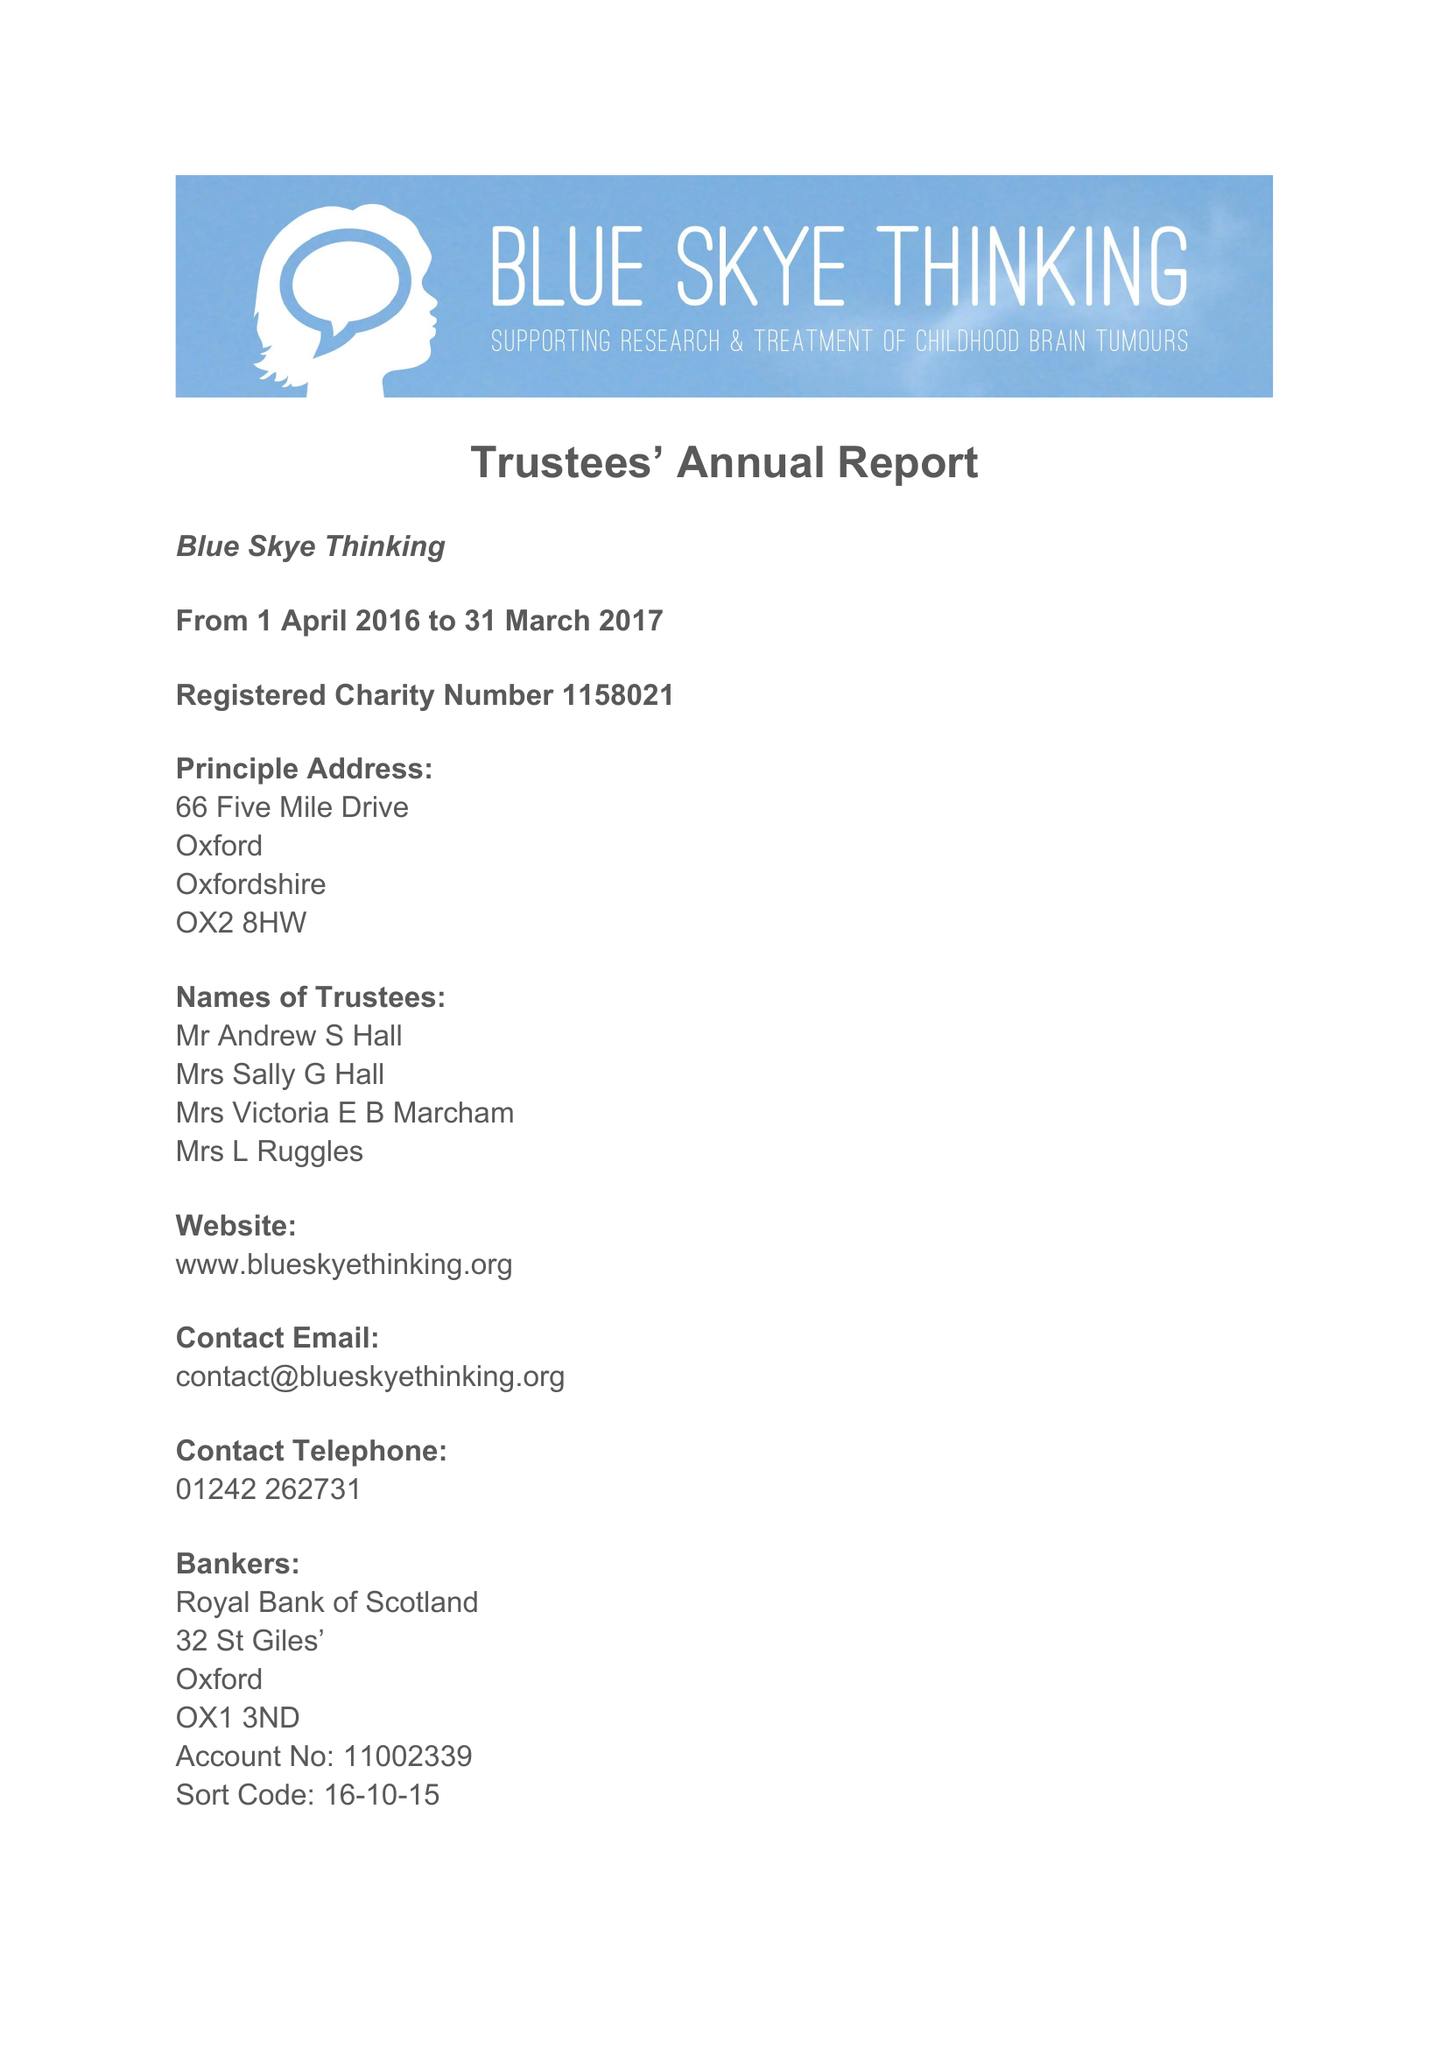What is the value for the address__post_town?
Answer the question using a single word or phrase. OXFORD 